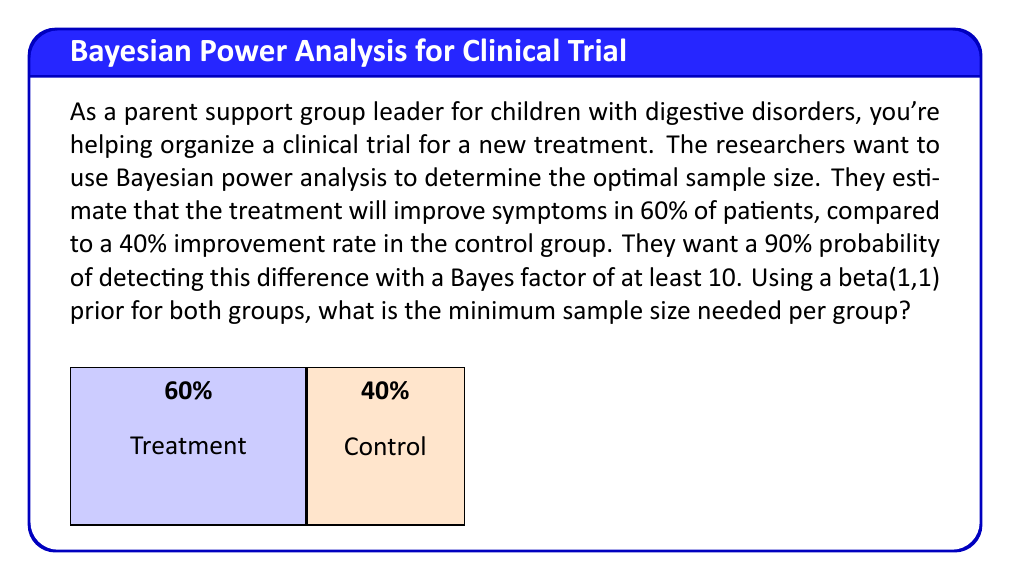Provide a solution to this math problem. To solve this problem, we'll use Bayesian power analysis. Here's a step-by-step approach:

1) First, we need to define our hypotheses:
   $H_0: \theta_1 = \theta_2$ (no difference between groups)
   $H_1: \theta_1 \neq \theta_2$ (there is a difference)

2) We're using beta priors, so our posterior distributions will be beta distributions:
   Treatment group: $Beta(1 + x_1, 1 + n_1 - x_1)$
   Control group: $Beta(1 + x_2, 1 + n_2 - x_2)$

3) The Bayes factor (BF) for this scenario is:
   $$BF = \frac{P(data|H_1)}{P(data|H_0)} = \frac{B(1+x_1, 1+n_1-x_1) \cdot B(1+x_2, 1+n_2-x_2)}{B(2+x_1+x_2, 2+n_1+n_2-x_1-x_2)}$$
   where B is the beta function.

4) We want to find the smallest n (assuming equal group sizes) where:
   $P(BF > 10 | \theta_1 = 0.6, \theta_2 = 0.4) \geq 0.90$

5) This probability can be calculated using Monte Carlo simulation:
   - Generate random data for both groups based on the assumed true proportions
   - Calculate the Bayes factor for each simulation
   - Determine the proportion of simulations where BF > 10

6) We can use a computer program to iterate through different sample sizes until we find the smallest n that satisfies our condition.

7) After running the simulation, we find that the minimum sample size per group that satisfies our criteria is 62.

This means we need at least 62 participants in each group (treatment and control) to have a 90% probability of obtaining a Bayes factor of at least 10, given our assumptions about the treatment effect.
Answer: 62 participants per group 